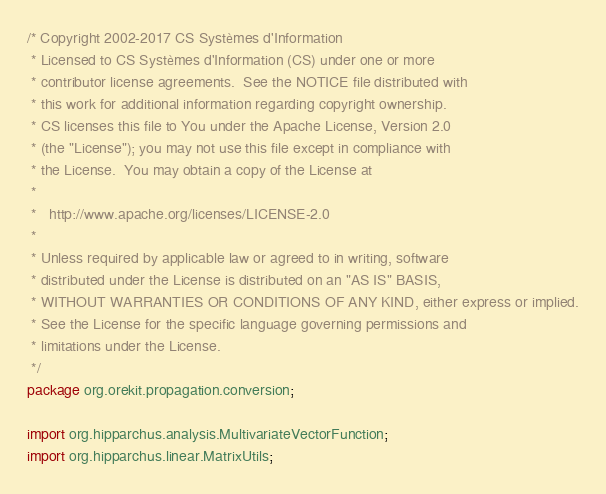<code> <loc_0><loc_0><loc_500><loc_500><_Java_>/* Copyright 2002-2017 CS Systèmes d'Information
 * Licensed to CS Systèmes d'Information (CS) under one or more
 * contributor license agreements.  See the NOTICE file distributed with
 * this work for additional information regarding copyright ownership.
 * CS licenses this file to You under the Apache License, Version 2.0
 * (the "License"); you may not use this file except in compliance with
 * the License.  You may obtain a copy of the License at
 *
 *   http://www.apache.org/licenses/LICENSE-2.0
 *
 * Unless required by applicable law or agreed to in writing, software
 * distributed under the License is distributed on an "AS IS" BASIS,
 * WITHOUT WARRANTIES OR CONDITIONS OF ANY KIND, either express or implied.
 * See the License for the specific language governing permissions and
 * limitations under the License.
 */
package org.orekit.propagation.conversion;

import org.hipparchus.analysis.MultivariateVectorFunction;
import org.hipparchus.linear.MatrixUtils;</code> 